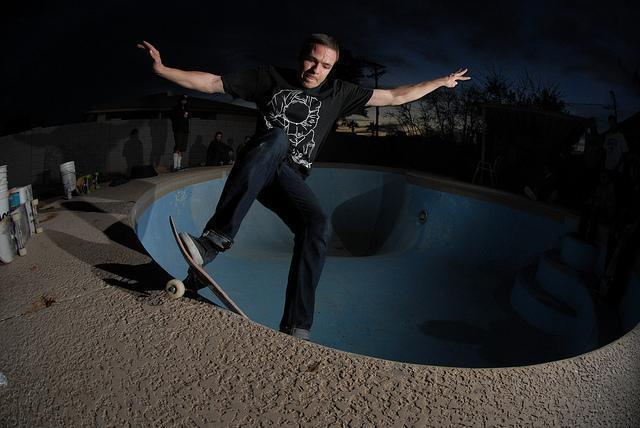How many skateboards are there?
Give a very brief answer. 1. How many horses are in the photo?
Give a very brief answer. 0. 